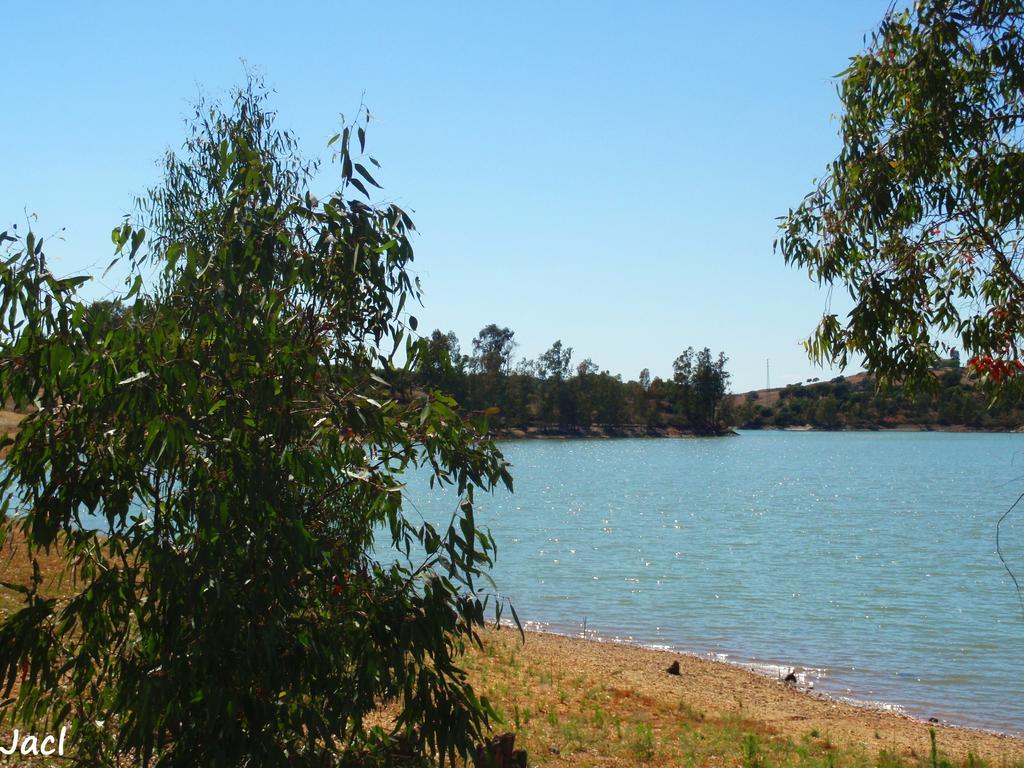How would you summarize this image in a sentence or two? In this image I can see number of trees, water, grass, the sky and here I can see watermark. 